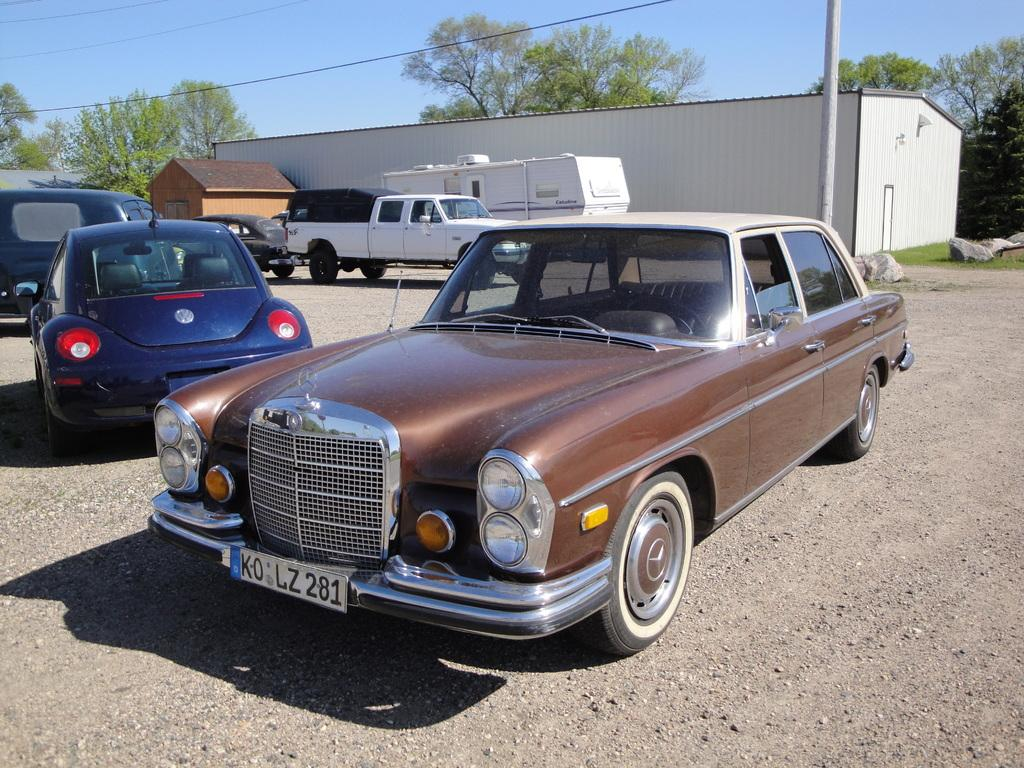What types of objects are present in the image? There are vehicles in the image. What else can be seen in the image besides the vehicles? There is text written in the image, and there is a building, trees, a pole, wires, and the sky visible in the background. Can you describe the background of the image? The background of the image includes a building, trees, a pole, wires, and the sky. What flavor of ice cream does the lawyer recommend in the image? There is no lawyer or ice cream present in the image, so it is not possible to answer that question. 